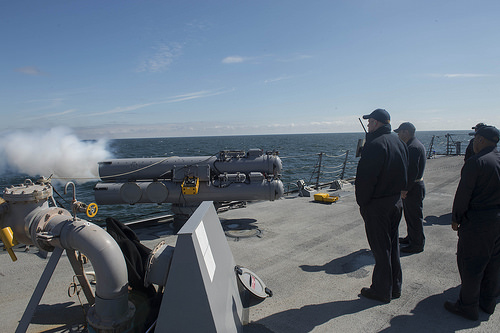<image>
Is the man on the floor? Yes. Looking at the image, I can see the man is positioned on top of the floor, with the floor providing support. 